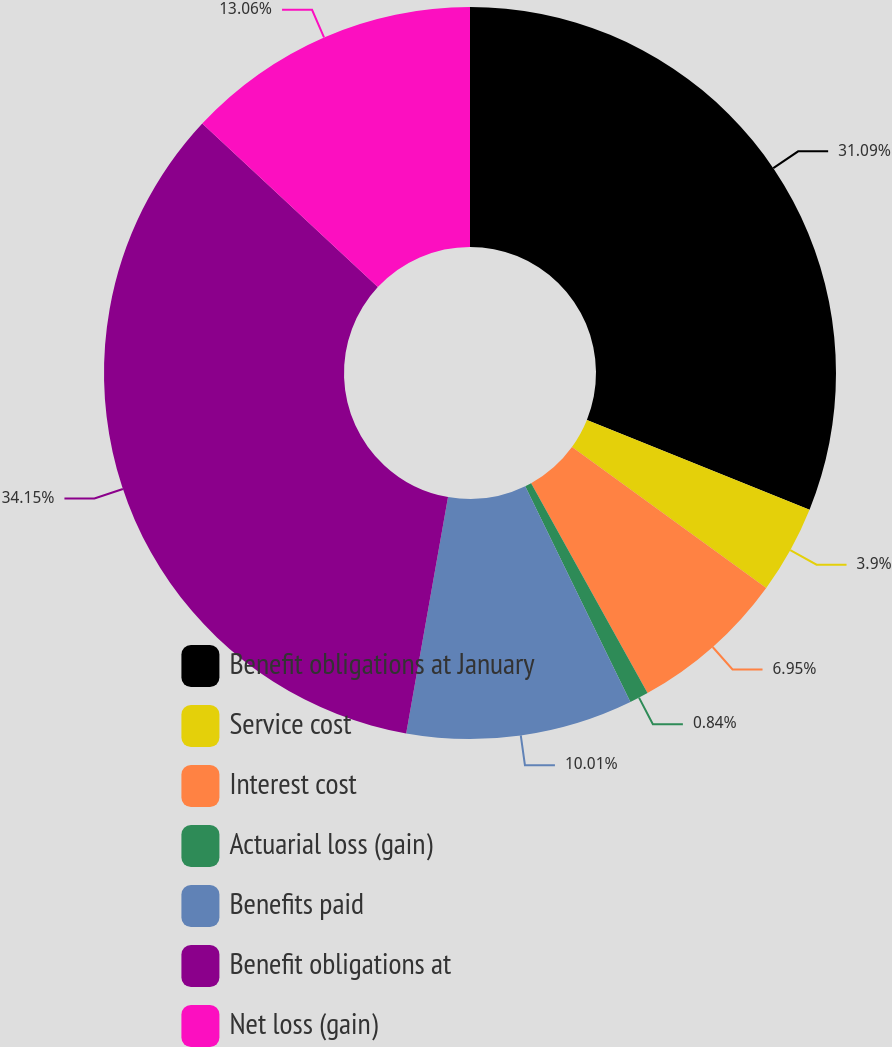Convert chart to OTSL. <chart><loc_0><loc_0><loc_500><loc_500><pie_chart><fcel>Benefit obligations at January<fcel>Service cost<fcel>Interest cost<fcel>Actuarial loss (gain)<fcel>Benefits paid<fcel>Benefit obligations at<fcel>Net loss (gain)<nl><fcel>31.09%<fcel>3.9%<fcel>6.95%<fcel>0.84%<fcel>10.01%<fcel>34.15%<fcel>13.06%<nl></chart> 